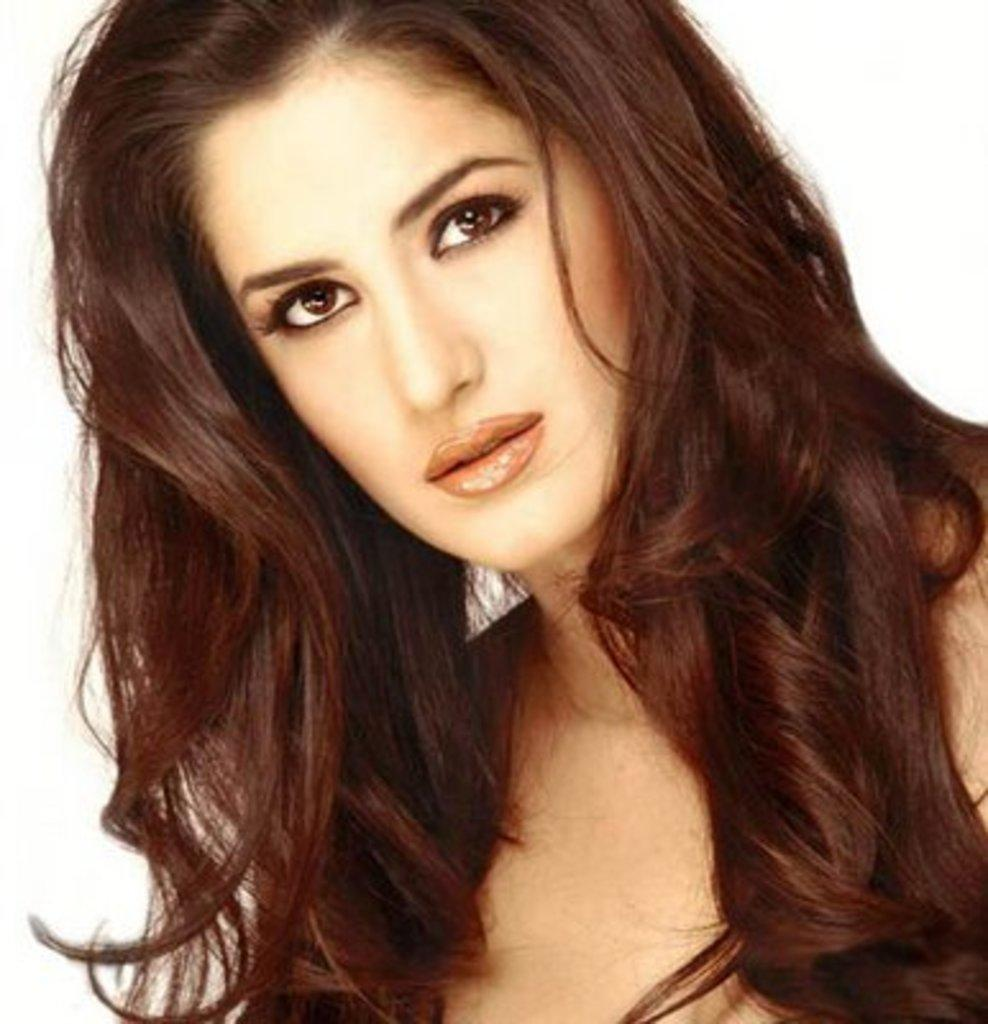Who is present in the image? There is a woman in the image. What can be seen behind the woman? The background of the image is white. What type of cat can be seen playing with a form in the image? There is no cat or form present in the image; it only features a woman with a white background. 